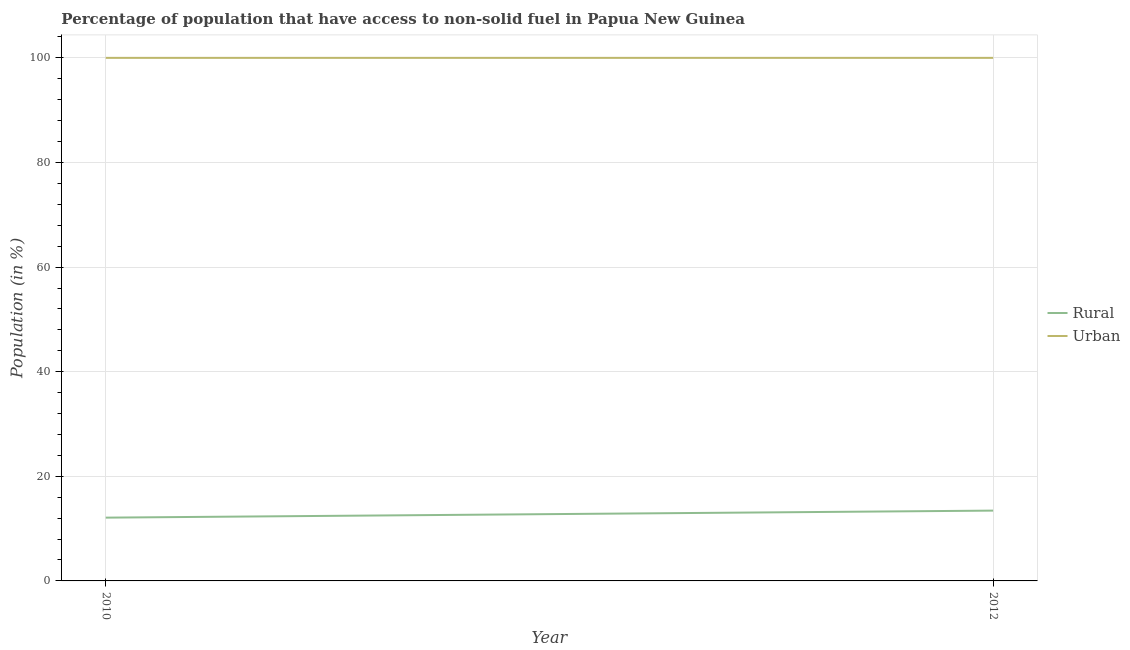How many different coloured lines are there?
Offer a very short reply. 2. Is the number of lines equal to the number of legend labels?
Keep it short and to the point. Yes. What is the rural population in 2010?
Make the answer very short. 12.1. Across all years, what is the maximum urban population?
Your answer should be compact. 100. Across all years, what is the minimum rural population?
Keep it short and to the point. 12.1. What is the total rural population in the graph?
Make the answer very short. 25.54. What is the difference between the urban population in 2010 and that in 2012?
Give a very brief answer. 0. What is the difference between the urban population in 2012 and the rural population in 2010?
Provide a short and direct response. 87.9. What is the average rural population per year?
Your answer should be compact. 12.77. In the year 2010, what is the difference between the urban population and rural population?
Ensure brevity in your answer.  87.9. In how many years, is the rural population greater than 12 %?
Provide a short and direct response. 2. What is the ratio of the urban population in 2010 to that in 2012?
Provide a short and direct response. 1. Is the urban population in 2010 less than that in 2012?
Your answer should be very brief. No. In how many years, is the rural population greater than the average rural population taken over all years?
Provide a short and direct response. 1. Does the urban population monotonically increase over the years?
Offer a very short reply. No. Is the rural population strictly less than the urban population over the years?
Your response must be concise. Yes. How many lines are there?
Your answer should be compact. 2. How many years are there in the graph?
Your response must be concise. 2. Are the values on the major ticks of Y-axis written in scientific E-notation?
Offer a very short reply. No. Does the graph contain grids?
Make the answer very short. Yes. How many legend labels are there?
Your response must be concise. 2. What is the title of the graph?
Give a very brief answer. Percentage of population that have access to non-solid fuel in Papua New Guinea. Does "Pregnant women" appear as one of the legend labels in the graph?
Provide a succinct answer. No. What is the label or title of the X-axis?
Make the answer very short. Year. What is the label or title of the Y-axis?
Provide a short and direct response. Population (in %). What is the Population (in %) in Rural in 2010?
Your response must be concise. 12.1. What is the Population (in %) in Urban in 2010?
Your answer should be very brief. 100. What is the Population (in %) of Rural in 2012?
Offer a terse response. 13.44. What is the Population (in %) in Urban in 2012?
Keep it short and to the point. 100. Across all years, what is the maximum Population (in %) in Rural?
Ensure brevity in your answer.  13.44. Across all years, what is the maximum Population (in %) of Urban?
Your answer should be compact. 100. Across all years, what is the minimum Population (in %) in Rural?
Give a very brief answer. 12.1. What is the total Population (in %) of Rural in the graph?
Offer a terse response. 25.54. What is the difference between the Population (in %) in Rural in 2010 and that in 2012?
Offer a terse response. -1.35. What is the difference between the Population (in %) in Urban in 2010 and that in 2012?
Make the answer very short. 0. What is the difference between the Population (in %) of Rural in 2010 and the Population (in %) of Urban in 2012?
Give a very brief answer. -87.9. What is the average Population (in %) of Rural per year?
Your response must be concise. 12.77. What is the average Population (in %) of Urban per year?
Provide a short and direct response. 100. In the year 2010, what is the difference between the Population (in %) of Rural and Population (in %) of Urban?
Your answer should be compact. -87.9. In the year 2012, what is the difference between the Population (in %) in Rural and Population (in %) in Urban?
Make the answer very short. -86.56. What is the ratio of the Population (in %) of Rural in 2010 to that in 2012?
Give a very brief answer. 0.9. What is the ratio of the Population (in %) in Urban in 2010 to that in 2012?
Provide a succinct answer. 1. What is the difference between the highest and the second highest Population (in %) of Rural?
Your answer should be very brief. 1.35. What is the difference between the highest and the lowest Population (in %) in Rural?
Provide a succinct answer. 1.35. What is the difference between the highest and the lowest Population (in %) of Urban?
Keep it short and to the point. 0. 